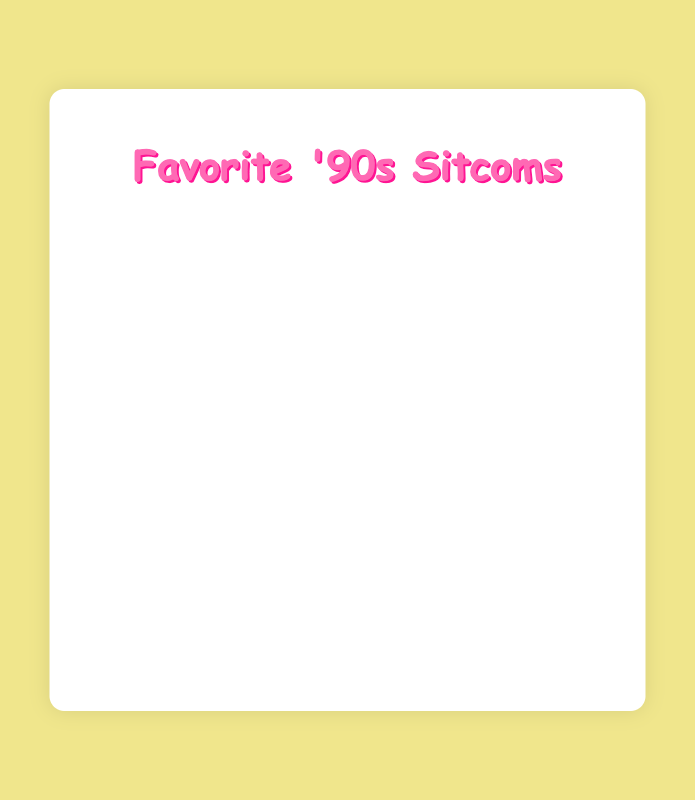What percentage of people chose Friends as their favorite sitcom? The pie chart shows that Friends was chosen by 40% of the people.
Answer: 40% Which sitcoms have the same percentage of preference? The pie chart shows that both Family Matters and Blossom have the same percentage of 10%.
Answer: Family Matters and Blossom How much higher is Friends' preference percentage compared to Full House? Friends has a preference percentage of 40%, and Full House has 15%. The difference is 40% - 15% = 25%.
Answer: 25% What is the combined percentage of people who chose Full House and Family Matters as their favorite sitcoms? The preference percentage for Full House is 15% and for Family Matters is 10%. The combined percentage is 15% + 10% = 25%.
Answer: 25% List the sitcoms in order of preference starting from the most preferred. Based on the pie chart, the list in order of preference is: Friends, The Fresh Prince of Bel-Air, Full House, Family Matters, Blossom.
Answer: Friends, The Fresh Prince of Bel-Air, Full House, Family Matters, Blossom Which sitcom has the second highest percentage of preference? The pie chart shows that The Fresh Prince of Bel-Air has the second highest percentage of 25%.
Answer: The Fresh Prince of Bel-Air Is the percentage of people who chose Friends greater than the combined percentage of those who chose Family Matters and Blossom? Friends has 40% preference. Family Matters and Blossom together have 10% + 10% = 20%. 40% is indeed greater than 20%.
Answer: Yes What is the total percentage of people who chose The Fresh Prince of Bel-Air and Blossom? The preference percentage for The Fresh Prince of Bel-Air is 25% and for Blossom is 10%. The total percentage is 25% + 10% = 35%.
Answer: 35% Which segment of the pie chart is colored in yellow? The pie chart shows that The Fresh Prince of Bel-Air is represented by the yellow segment.
Answer: The Fresh Prince of Bel-Air How much of a lead does Friends have over The Fresh Prince of Bel-Air in terms of preference percentage? Friends has 40% preference, and The Fresh Prince of Bel-Air has 25%. The lead is 40% - 25% = 15%.
Answer: 15% 